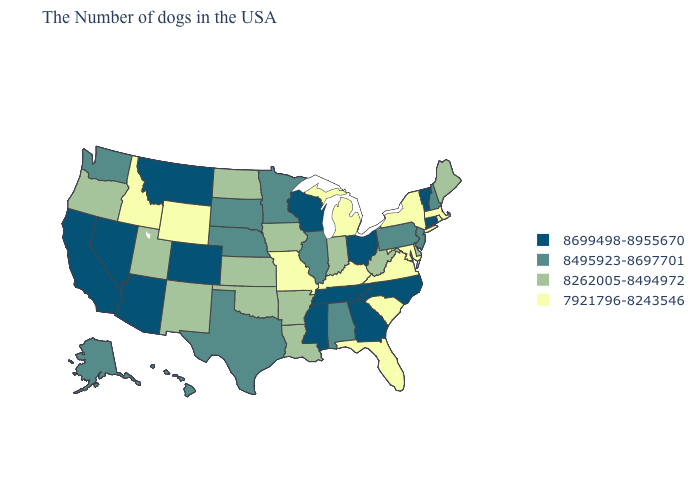What is the value of Arkansas?
Give a very brief answer. 8262005-8494972. What is the value of Florida?
Answer briefly. 7921796-8243546. Which states hav the highest value in the Northeast?
Quick response, please. Vermont, Connecticut. Does Idaho have the lowest value in the West?
Keep it brief. Yes. Which states have the lowest value in the USA?
Write a very short answer. Massachusetts, Rhode Island, New York, Maryland, Virginia, South Carolina, Florida, Michigan, Kentucky, Missouri, Wyoming, Idaho. What is the highest value in states that border Ohio?
Be succinct. 8495923-8697701. Does Arizona have the highest value in the USA?
Short answer required. Yes. Does Utah have a higher value than Minnesota?
Concise answer only. No. Name the states that have a value in the range 8495923-8697701?
Give a very brief answer. New Hampshire, New Jersey, Pennsylvania, Alabama, Illinois, Minnesota, Nebraska, Texas, South Dakota, Washington, Alaska, Hawaii. Among the states that border Michigan , does Indiana have the highest value?
Write a very short answer. No. Which states have the lowest value in the West?
Give a very brief answer. Wyoming, Idaho. Does North Carolina have the highest value in the USA?
Keep it brief. Yes. Does Kansas have a lower value than Massachusetts?
Short answer required. No. Does the first symbol in the legend represent the smallest category?
Answer briefly. No. How many symbols are there in the legend?
Answer briefly. 4. 